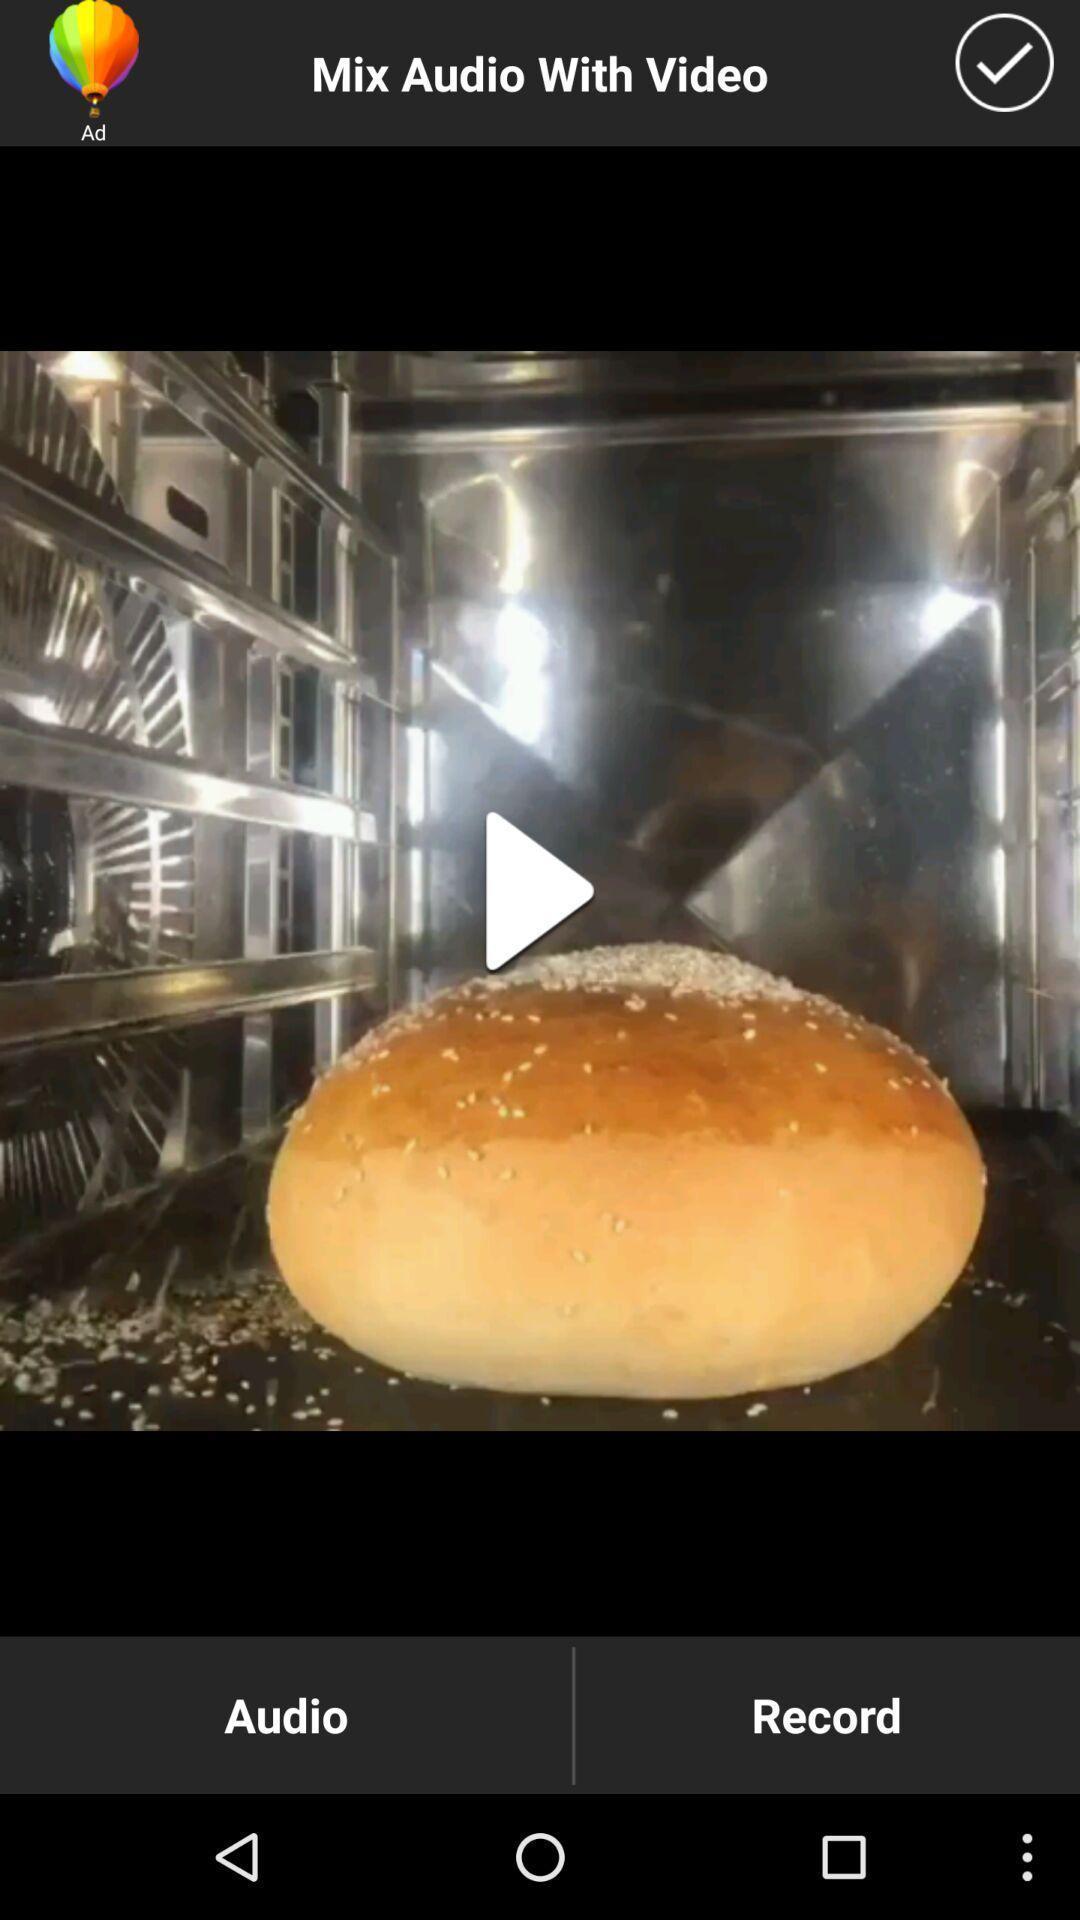Describe the key features of this screenshot. Play symbol showing in this page. 